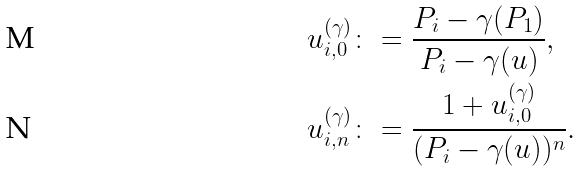Convert formula to latex. <formula><loc_0><loc_0><loc_500><loc_500>& u _ { i , 0 } ^ { ( \gamma ) } \colon = \frac { P _ { i } - \gamma ( P _ { 1 } ) } { P _ { i } - \gamma ( u ) } , \\ & u _ { i , n } ^ { ( \gamma ) } \colon = \frac { 1 + u _ { i , 0 } ^ { ( \gamma ) } } { ( P _ { i } - \gamma ( u ) ) ^ { n } } .</formula> 